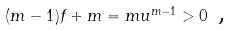<formula> <loc_0><loc_0><loc_500><loc_500>( m - 1 ) f + m = m u ^ { m - 1 } > 0 \text { ,}</formula> 